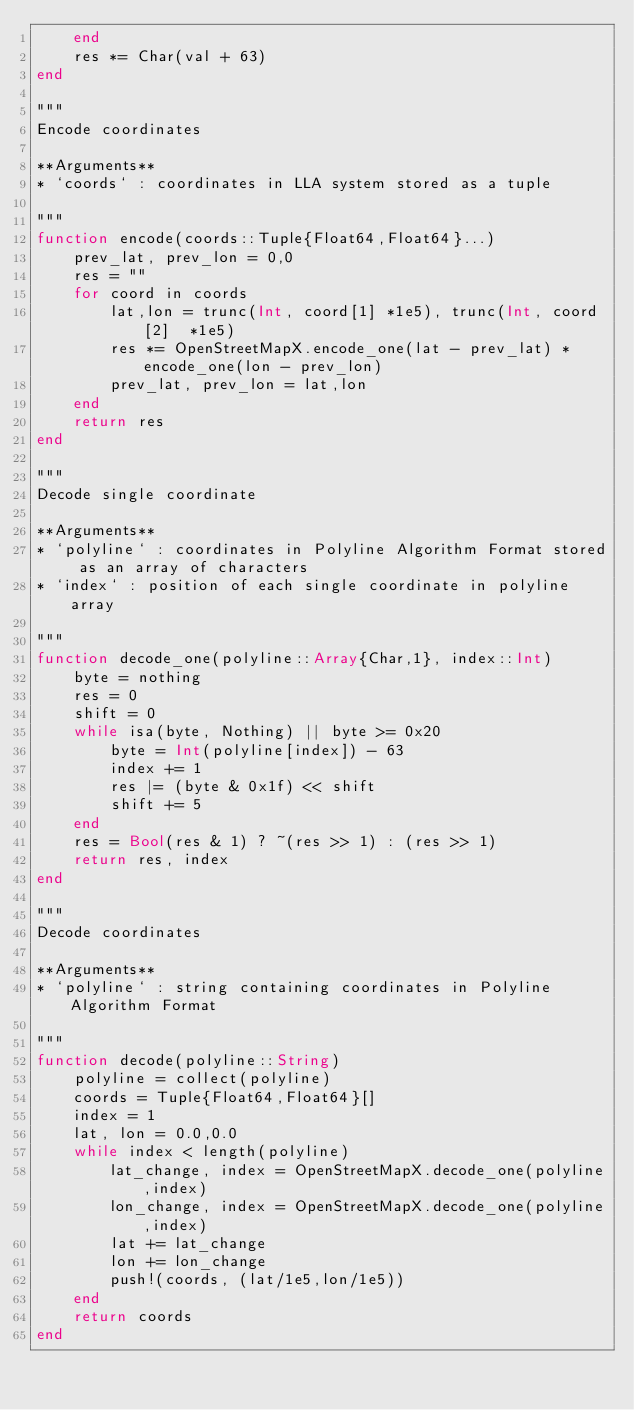Convert code to text. <code><loc_0><loc_0><loc_500><loc_500><_Julia_>    end
    res *= Char(val + 63)
end

"""
Encode coordinates 

**Arguments**
* `coords` : coordinates in LLA system stored as a tuple

"""
function encode(coords::Tuple{Float64,Float64}...)
    prev_lat, prev_lon = 0,0
    res = ""
    for coord in coords
        lat,lon = trunc(Int, coord[1] *1e5), trunc(Int, coord[2]  *1e5) 
        res *= OpenStreetMapX.encode_one(lat - prev_lat) * encode_one(lon - prev_lon)
        prev_lat, prev_lon = lat,lon
    end
    return res
end

"""
Decode single coordinate

**Arguments**
* `polyline` : coordinates in Polyline Algorithm Format stored as an array of characters
* `index` : position of each single coordinate in polyline array

"""
function decode_one(polyline::Array{Char,1}, index::Int)
    byte = nothing
    res = 0
    shift = 0
    while isa(byte, Nothing) || byte >= 0x20
        byte = Int(polyline[index]) - 63
        index += 1
        res |= (byte & 0x1f) << shift
        shift += 5
    end
    res = Bool(res & 1) ? ~(res >> 1) : (res >> 1)
    return res, index
end

"""
Decode coordinates 

**Arguments**
* `polyline` : string containing coordinates in Polyline Algorithm Format

"""
function decode(polyline::String)
    polyline = collect(polyline)
    coords = Tuple{Float64,Float64}[]
    index = 1 
    lat, lon = 0.0,0.0
    while index < length(polyline)
        lat_change, index = OpenStreetMapX.decode_one(polyline,index)
        lon_change, index = OpenStreetMapX.decode_one(polyline,index)
        lat += lat_change
        lon += lon_change
        push!(coords, (lat/1e5,lon/1e5))
    end
    return coords
end</code> 